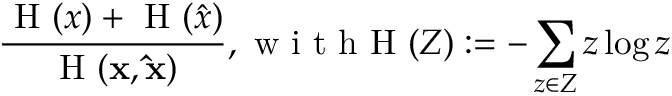Convert formula to latex. <formula><loc_0><loc_0><loc_500><loc_500>\frac { H ( x ) + H ( \hat { x } ) } { H ( x , \hat { x } ) } , w i t h H ( Z ) \colon = - \sum _ { z \in Z } z \log z</formula> 